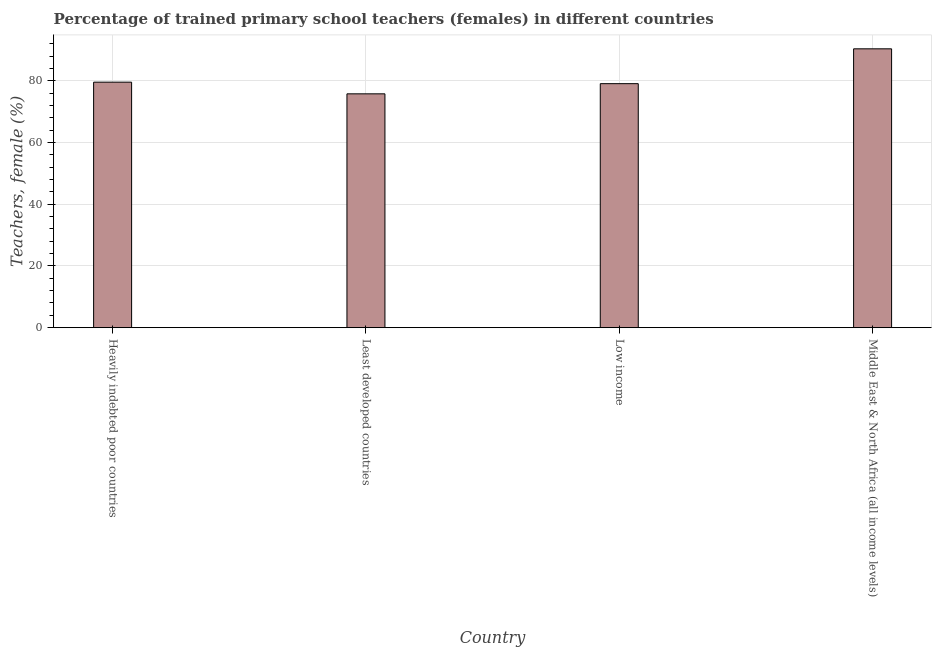Does the graph contain grids?
Provide a succinct answer. Yes. What is the title of the graph?
Ensure brevity in your answer.  Percentage of trained primary school teachers (females) in different countries. What is the label or title of the X-axis?
Give a very brief answer. Country. What is the label or title of the Y-axis?
Ensure brevity in your answer.  Teachers, female (%). What is the percentage of trained female teachers in Middle East & North Africa (all income levels)?
Offer a terse response. 90.34. Across all countries, what is the maximum percentage of trained female teachers?
Your response must be concise. 90.34. Across all countries, what is the minimum percentage of trained female teachers?
Your response must be concise. 75.75. In which country was the percentage of trained female teachers maximum?
Give a very brief answer. Middle East & North Africa (all income levels). In which country was the percentage of trained female teachers minimum?
Your answer should be very brief. Least developed countries. What is the sum of the percentage of trained female teachers?
Your answer should be very brief. 324.67. What is the difference between the percentage of trained female teachers in Heavily indebted poor countries and Low income?
Offer a terse response. 0.48. What is the average percentage of trained female teachers per country?
Your answer should be compact. 81.17. What is the median percentage of trained female teachers?
Provide a short and direct response. 79.29. In how many countries, is the percentage of trained female teachers greater than 24 %?
Keep it short and to the point. 4. What is the ratio of the percentage of trained female teachers in Low income to that in Middle East & North Africa (all income levels)?
Provide a succinct answer. 0.88. Is the difference between the percentage of trained female teachers in Least developed countries and Middle East & North Africa (all income levels) greater than the difference between any two countries?
Your answer should be very brief. Yes. What is the difference between the highest and the second highest percentage of trained female teachers?
Keep it short and to the point. 10.8. Is the sum of the percentage of trained female teachers in Heavily indebted poor countries and Middle East & North Africa (all income levels) greater than the maximum percentage of trained female teachers across all countries?
Ensure brevity in your answer.  Yes. What is the difference between the highest and the lowest percentage of trained female teachers?
Your answer should be compact. 14.59. Are all the bars in the graph horizontal?
Give a very brief answer. No. Are the values on the major ticks of Y-axis written in scientific E-notation?
Give a very brief answer. No. What is the Teachers, female (%) in Heavily indebted poor countries?
Keep it short and to the point. 79.53. What is the Teachers, female (%) of Least developed countries?
Keep it short and to the point. 75.75. What is the Teachers, female (%) of Low income?
Ensure brevity in your answer.  79.05. What is the Teachers, female (%) of Middle East & North Africa (all income levels)?
Provide a short and direct response. 90.34. What is the difference between the Teachers, female (%) in Heavily indebted poor countries and Least developed countries?
Provide a short and direct response. 3.78. What is the difference between the Teachers, female (%) in Heavily indebted poor countries and Low income?
Make the answer very short. 0.48. What is the difference between the Teachers, female (%) in Heavily indebted poor countries and Middle East & North Africa (all income levels)?
Ensure brevity in your answer.  -10.81. What is the difference between the Teachers, female (%) in Least developed countries and Low income?
Your answer should be very brief. -3.3. What is the difference between the Teachers, female (%) in Least developed countries and Middle East & North Africa (all income levels)?
Your answer should be compact. -14.59. What is the difference between the Teachers, female (%) in Low income and Middle East & North Africa (all income levels)?
Provide a succinct answer. -11.29. What is the ratio of the Teachers, female (%) in Least developed countries to that in Low income?
Make the answer very short. 0.96. What is the ratio of the Teachers, female (%) in Least developed countries to that in Middle East & North Africa (all income levels)?
Ensure brevity in your answer.  0.84. What is the ratio of the Teachers, female (%) in Low income to that in Middle East & North Africa (all income levels)?
Keep it short and to the point. 0.88. 